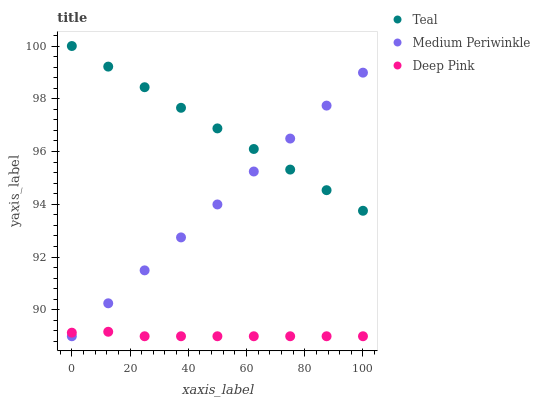Does Deep Pink have the minimum area under the curve?
Answer yes or no. Yes. Does Teal have the maximum area under the curve?
Answer yes or no. Yes. Does Medium Periwinkle have the minimum area under the curve?
Answer yes or no. No. Does Medium Periwinkle have the maximum area under the curve?
Answer yes or no. No. Is Medium Periwinkle the smoothest?
Answer yes or no. Yes. Is Deep Pink the roughest?
Answer yes or no. Yes. Is Teal the smoothest?
Answer yes or no. No. Is Teal the roughest?
Answer yes or no. No. Does Deep Pink have the lowest value?
Answer yes or no. Yes. Does Teal have the lowest value?
Answer yes or no. No. Does Teal have the highest value?
Answer yes or no. Yes. Does Medium Periwinkle have the highest value?
Answer yes or no. No. Is Deep Pink less than Teal?
Answer yes or no. Yes. Is Teal greater than Deep Pink?
Answer yes or no. Yes. Does Medium Periwinkle intersect Teal?
Answer yes or no. Yes. Is Medium Periwinkle less than Teal?
Answer yes or no. No. Is Medium Periwinkle greater than Teal?
Answer yes or no. No. Does Deep Pink intersect Teal?
Answer yes or no. No. 